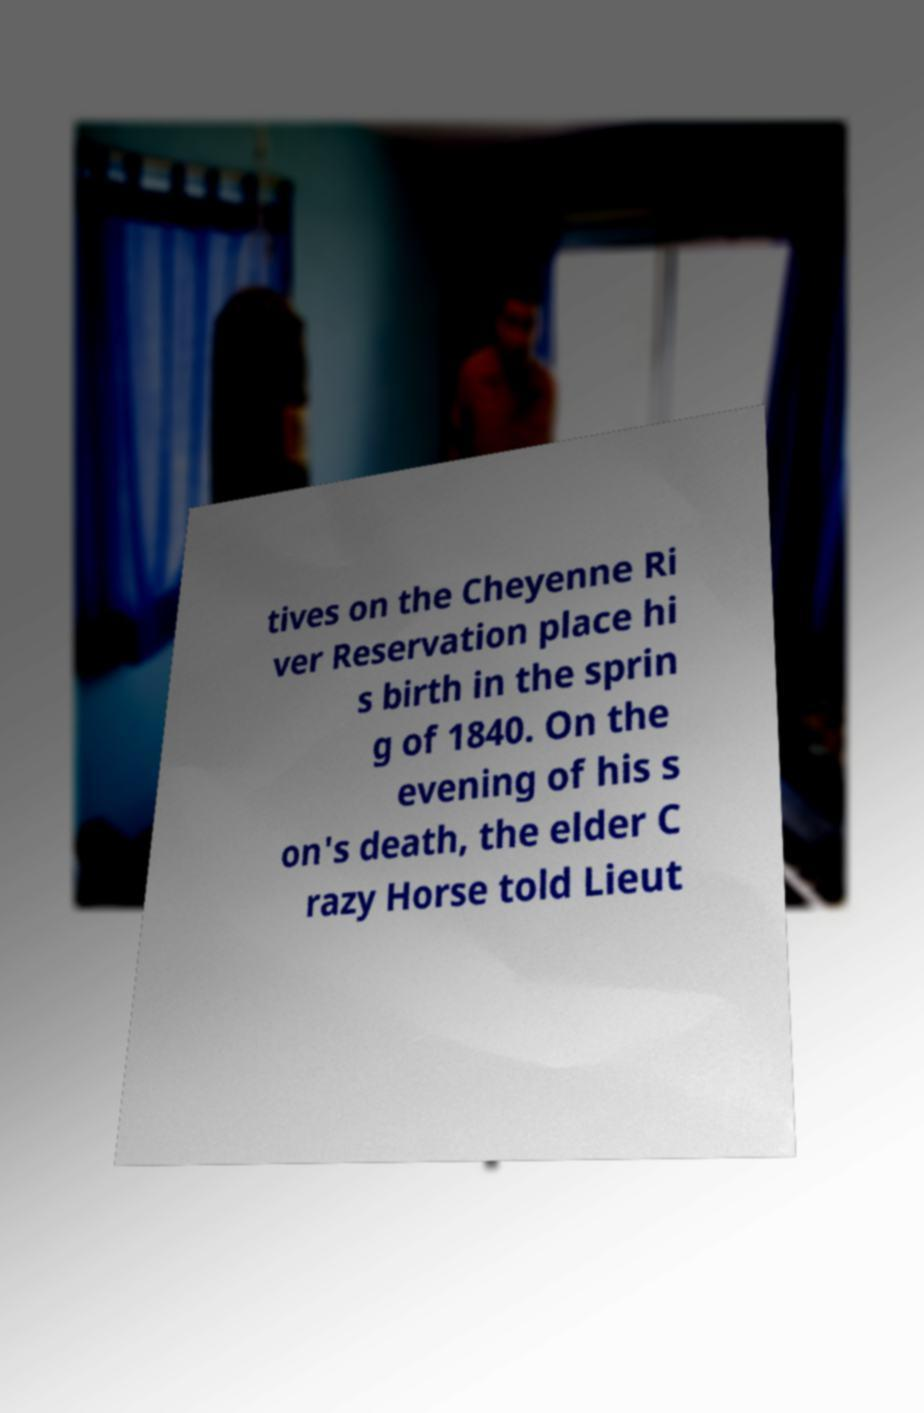For documentation purposes, I need the text within this image transcribed. Could you provide that? tives on the Cheyenne Ri ver Reservation place hi s birth in the sprin g of 1840. On the evening of his s on's death, the elder C razy Horse told Lieut 